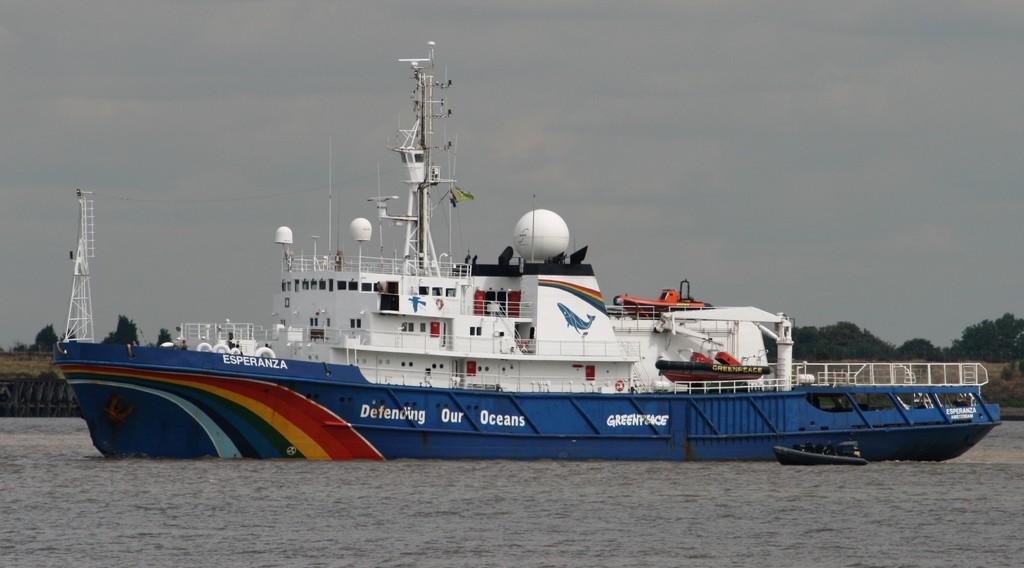What does the boat defend?
Offer a terse response. Our oceans. 